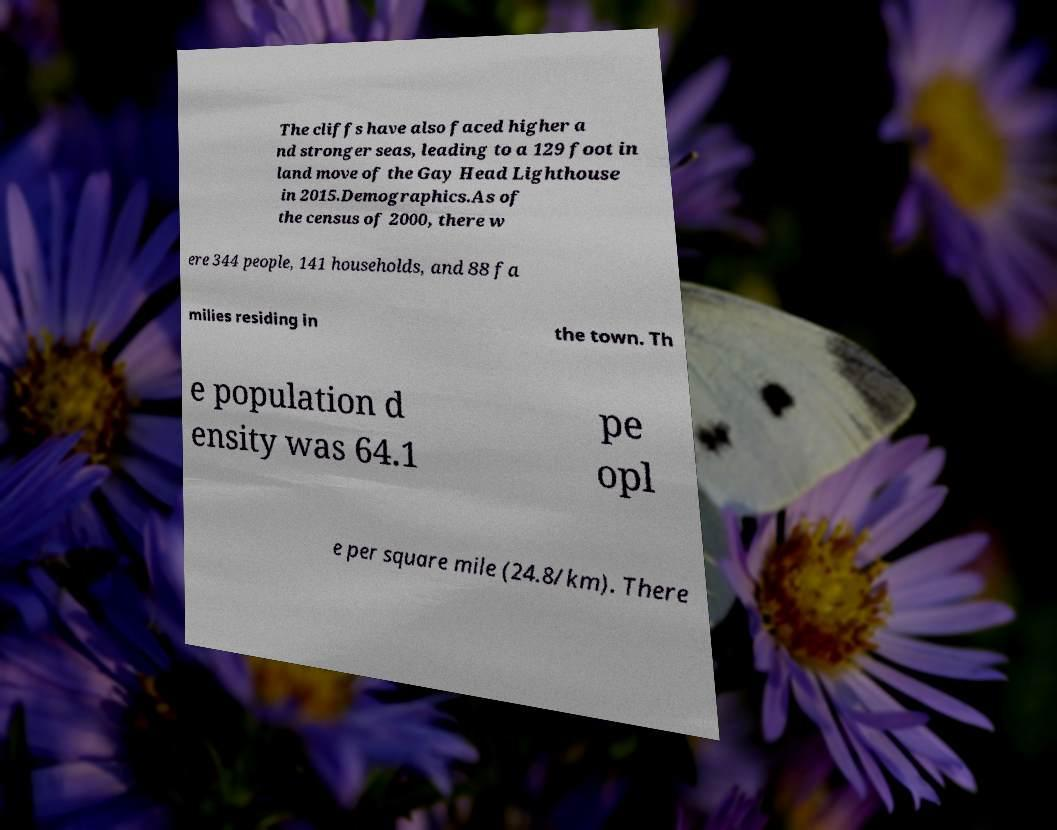Please read and relay the text visible in this image. What does it say? The cliffs have also faced higher a nd stronger seas, leading to a 129 foot in land move of the Gay Head Lighthouse in 2015.Demographics.As of the census of 2000, there w ere 344 people, 141 households, and 88 fa milies residing in the town. Th e population d ensity was 64.1 pe opl e per square mile (24.8/km). There 